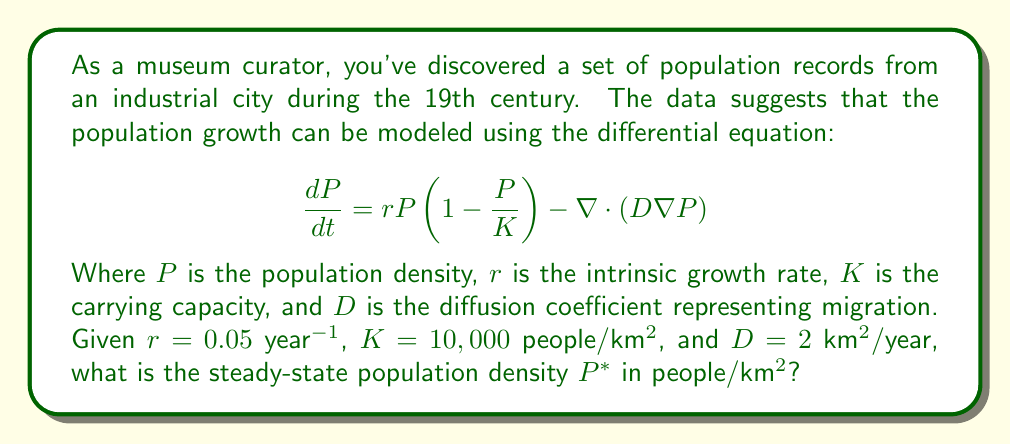Provide a solution to this math problem. To find the steady-state population density, we need to solve the equation when $\frac{dP}{dt} = 0$. At steady state, there is no net migration, so the diffusion term becomes zero. Thus, we have:

1) Set $\frac{dP}{dt} = 0$:
   $$0 = rP(1-\frac{P}{K}) - \nabla \cdot (D\nabla P)$$

2) The diffusion term $\nabla \cdot (D\nabla P) = 0$ at steady state, so:
   $$0 = rP(1-\frac{P}{K})$$

3) Factor out $P$:
   $$0 = P(r-\frac{rP}{K})$$

4) This equation is satisfied when either $P = 0$ or $r-\frac{rP}{K} = 0$. The non-zero solution is of interest, so:
   $$r-\frac{rP}{K} = 0$$

5) Solve for $P$:
   $$r = \frac{rP}{K}$$
   $$K = P$$

6) Therefore, the steady-state population density $P^*$ is equal to the carrying capacity $K$:
   $$P^* = K = 10,000 \text{ people/km}^2$$
Answer: 10,000 people/km$^2$ 